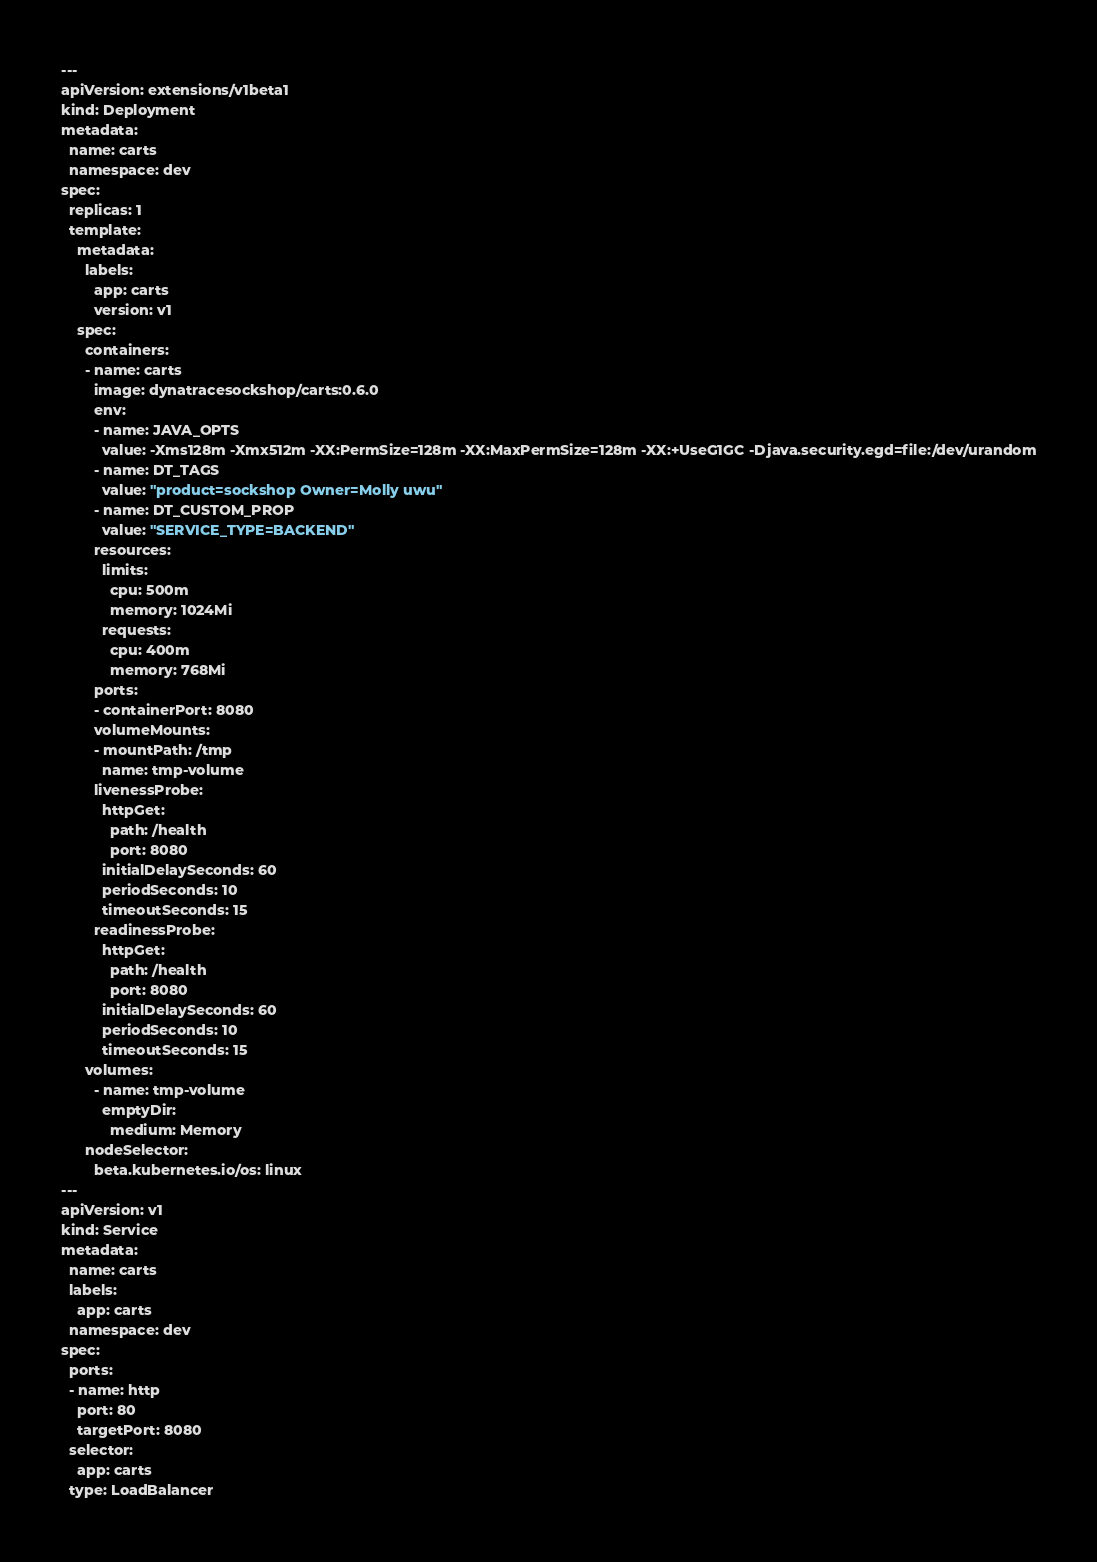Convert code to text. <code><loc_0><loc_0><loc_500><loc_500><_YAML_>---
apiVersion: extensions/v1beta1
kind: Deployment
metadata:
  name: carts
  namespace: dev
spec:
  replicas: 1
  template:
    metadata:
      labels:
        app: carts
        version: v1
    spec:
      containers:
      - name: carts
        image: dynatracesockshop/carts:0.6.0
        env:
        - name: JAVA_OPTS
          value: -Xms128m -Xmx512m -XX:PermSize=128m -XX:MaxPermSize=128m -XX:+UseG1GC -Djava.security.egd=file:/dev/urandom
        - name: DT_TAGS
          value: "product=sockshop Owner=Molly uwu"
        - name: DT_CUSTOM_PROP
          value: "SERVICE_TYPE=BACKEND"
        resources:
          limits:
            cpu: 500m
            memory: 1024Mi
          requests:
            cpu: 400m
            memory: 768Mi
        ports:
        - containerPort: 8080
        volumeMounts:
        - mountPath: /tmp
          name: tmp-volume
        livenessProbe:
          httpGet:
            path: /health
            port: 8080
          initialDelaySeconds: 60
          periodSeconds: 10
          timeoutSeconds: 15
        readinessProbe:
          httpGet:
            path: /health
            port: 8080
          initialDelaySeconds: 60
          periodSeconds: 10
          timeoutSeconds: 15
      volumes:
        - name: tmp-volume
          emptyDir:
            medium: Memory
      nodeSelector:
        beta.kubernetes.io/os: linux
---
apiVersion: v1
kind: Service
metadata:
  name: carts
  labels:
    app: carts
  namespace: dev
spec:
  ports:
  - name: http
    port: 80
    targetPort: 8080
  selector:
    app: carts
  type: LoadBalancer
</code> 